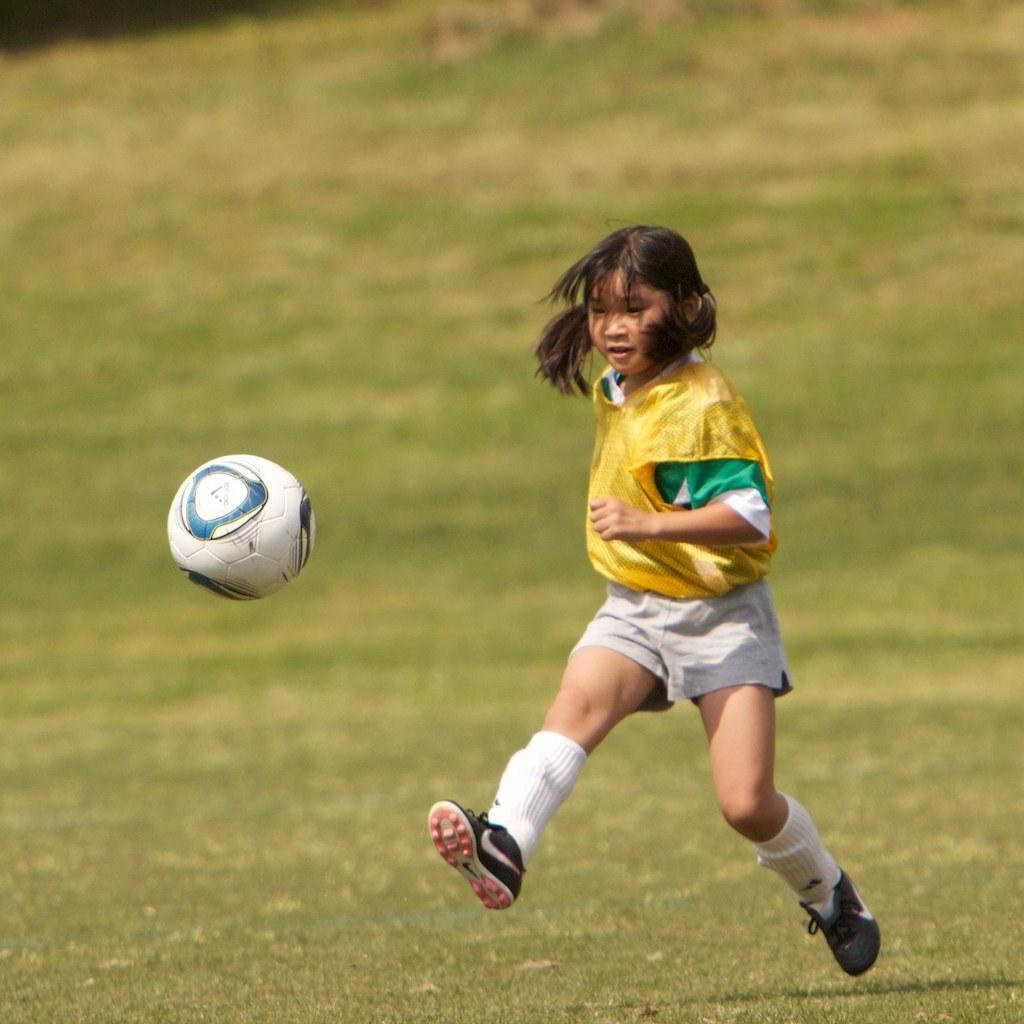Who is the main subject in the image? There is a girl in the image. What is the girl doing in the image? The girl is running. What can be seen on the left side of the image? There is a ball on the left side of the image. What type of surface is visible at the bottom of the image? There is grass at the bottom of the image. How many legs does the pear have in the image? There is no pear present in the image, so it is not possible to determine the number of legs it might have. Is the girl holding an umbrella in the image? There is no umbrella visible in the image; the girl is running and there is a ball on the left side of the image. 